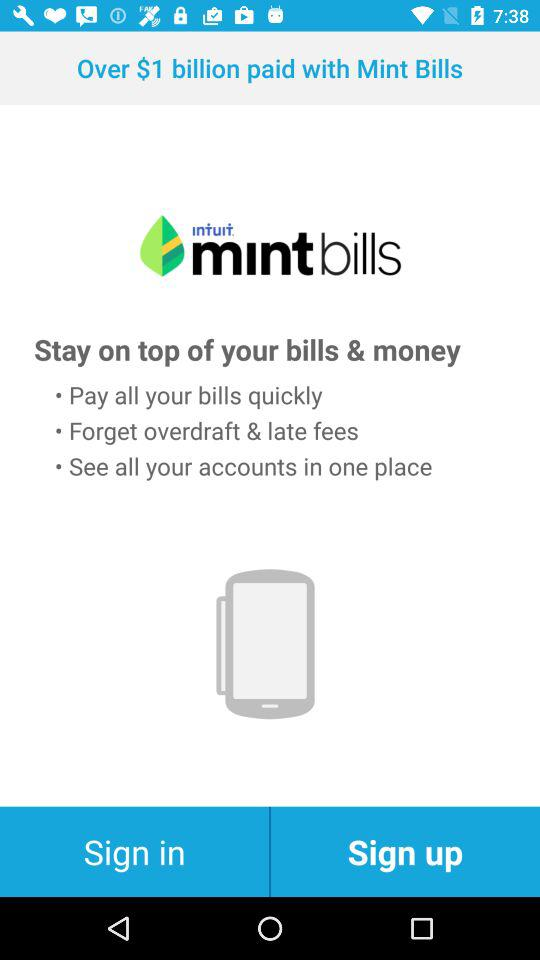How much amount was paid with "Mint Bills"? The amount paid with "Mint Bills" was over $1 billion. 